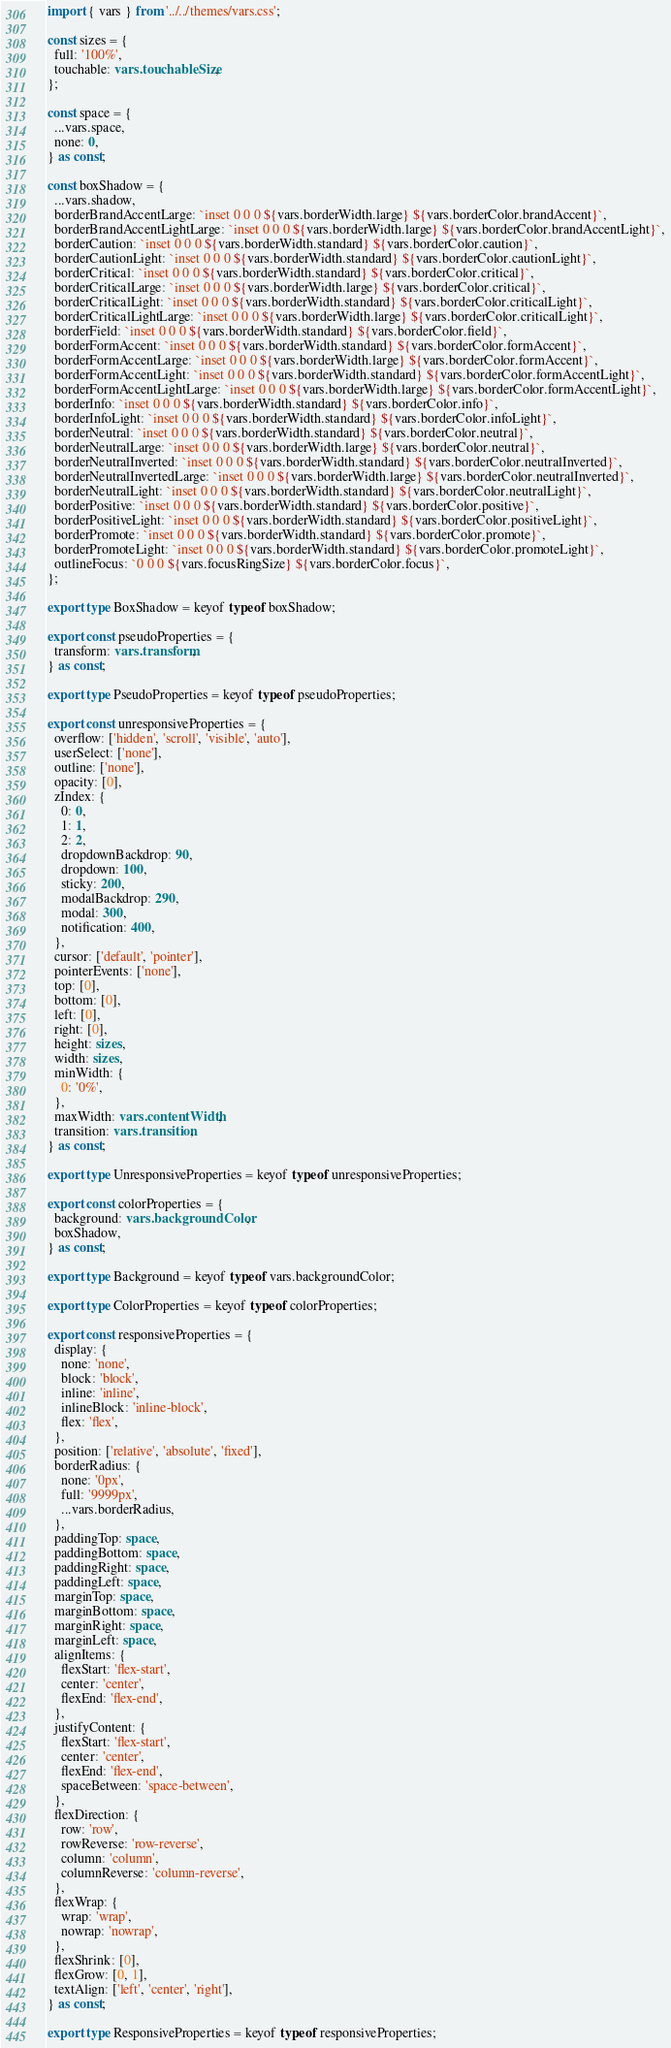<code> <loc_0><loc_0><loc_500><loc_500><_TypeScript_>import { vars } from '../../themes/vars.css';

const sizes = {
  full: '100%',
  touchable: vars.touchableSize,
};

const space = {
  ...vars.space,
  none: 0,
} as const;

const boxShadow = {
  ...vars.shadow,
  borderBrandAccentLarge: `inset 0 0 0 ${vars.borderWidth.large} ${vars.borderColor.brandAccent}`,
  borderBrandAccentLightLarge: `inset 0 0 0 ${vars.borderWidth.large} ${vars.borderColor.brandAccentLight}`,
  borderCaution: `inset 0 0 0 ${vars.borderWidth.standard} ${vars.borderColor.caution}`,
  borderCautionLight: `inset 0 0 0 ${vars.borderWidth.standard} ${vars.borderColor.cautionLight}`,
  borderCritical: `inset 0 0 0 ${vars.borderWidth.standard} ${vars.borderColor.critical}`,
  borderCriticalLarge: `inset 0 0 0 ${vars.borderWidth.large} ${vars.borderColor.critical}`,
  borderCriticalLight: `inset 0 0 0 ${vars.borderWidth.standard} ${vars.borderColor.criticalLight}`,
  borderCriticalLightLarge: `inset 0 0 0 ${vars.borderWidth.large} ${vars.borderColor.criticalLight}`,
  borderField: `inset 0 0 0 ${vars.borderWidth.standard} ${vars.borderColor.field}`,
  borderFormAccent: `inset 0 0 0 ${vars.borderWidth.standard} ${vars.borderColor.formAccent}`,
  borderFormAccentLarge: `inset 0 0 0 ${vars.borderWidth.large} ${vars.borderColor.formAccent}`,
  borderFormAccentLight: `inset 0 0 0 ${vars.borderWidth.standard} ${vars.borderColor.formAccentLight}`,
  borderFormAccentLightLarge: `inset 0 0 0 ${vars.borderWidth.large} ${vars.borderColor.formAccentLight}`,
  borderInfo: `inset 0 0 0 ${vars.borderWidth.standard} ${vars.borderColor.info}`,
  borderInfoLight: `inset 0 0 0 ${vars.borderWidth.standard} ${vars.borderColor.infoLight}`,
  borderNeutral: `inset 0 0 0 ${vars.borderWidth.standard} ${vars.borderColor.neutral}`,
  borderNeutralLarge: `inset 0 0 0 ${vars.borderWidth.large} ${vars.borderColor.neutral}`,
  borderNeutralInverted: `inset 0 0 0 ${vars.borderWidth.standard} ${vars.borderColor.neutralInverted}`,
  borderNeutralInvertedLarge: `inset 0 0 0 ${vars.borderWidth.large} ${vars.borderColor.neutralInverted}`,
  borderNeutralLight: `inset 0 0 0 ${vars.borderWidth.standard} ${vars.borderColor.neutralLight}`,
  borderPositive: `inset 0 0 0 ${vars.borderWidth.standard} ${vars.borderColor.positive}`,
  borderPositiveLight: `inset 0 0 0 ${vars.borderWidth.standard} ${vars.borderColor.positiveLight}`,
  borderPromote: `inset 0 0 0 ${vars.borderWidth.standard} ${vars.borderColor.promote}`,
  borderPromoteLight: `inset 0 0 0 ${vars.borderWidth.standard} ${vars.borderColor.promoteLight}`,
  outlineFocus: `0 0 0 ${vars.focusRingSize} ${vars.borderColor.focus}`,
};

export type BoxShadow = keyof typeof boxShadow;

export const pseudoProperties = {
  transform: vars.transform,
} as const;

export type PseudoProperties = keyof typeof pseudoProperties;

export const unresponsiveProperties = {
  overflow: ['hidden', 'scroll', 'visible', 'auto'],
  userSelect: ['none'],
  outline: ['none'],
  opacity: [0],
  zIndex: {
    0: 0,
    1: 1,
    2: 2,
    dropdownBackdrop: 90,
    dropdown: 100,
    sticky: 200,
    modalBackdrop: 290,
    modal: 300,
    notification: 400,
  },
  cursor: ['default', 'pointer'],
  pointerEvents: ['none'],
  top: [0],
  bottom: [0],
  left: [0],
  right: [0],
  height: sizes,
  width: sizes,
  minWidth: {
    0: '0%',
  },
  maxWidth: vars.contentWidth,
  transition: vars.transition,
} as const;

export type UnresponsiveProperties = keyof typeof unresponsiveProperties;

export const colorProperties = {
  background: vars.backgroundColor,
  boxShadow,
} as const;

export type Background = keyof typeof vars.backgroundColor;

export type ColorProperties = keyof typeof colorProperties;

export const responsiveProperties = {
  display: {
    none: 'none',
    block: 'block',
    inline: 'inline',
    inlineBlock: 'inline-block',
    flex: 'flex',
  },
  position: ['relative', 'absolute', 'fixed'],
  borderRadius: {
    none: '0px',
    full: '9999px',
    ...vars.borderRadius,
  },
  paddingTop: space,
  paddingBottom: space,
  paddingRight: space,
  paddingLeft: space,
  marginTop: space,
  marginBottom: space,
  marginRight: space,
  marginLeft: space,
  alignItems: {
    flexStart: 'flex-start',
    center: 'center',
    flexEnd: 'flex-end',
  },
  justifyContent: {
    flexStart: 'flex-start',
    center: 'center',
    flexEnd: 'flex-end',
    spaceBetween: 'space-between',
  },
  flexDirection: {
    row: 'row',
    rowReverse: 'row-reverse',
    column: 'column',
    columnReverse: 'column-reverse',
  },
  flexWrap: {
    wrap: 'wrap',
    nowrap: 'nowrap',
  },
  flexShrink: [0],
  flexGrow: [0, 1],
  textAlign: ['left', 'center', 'right'],
} as const;

export type ResponsiveProperties = keyof typeof responsiveProperties;
</code> 